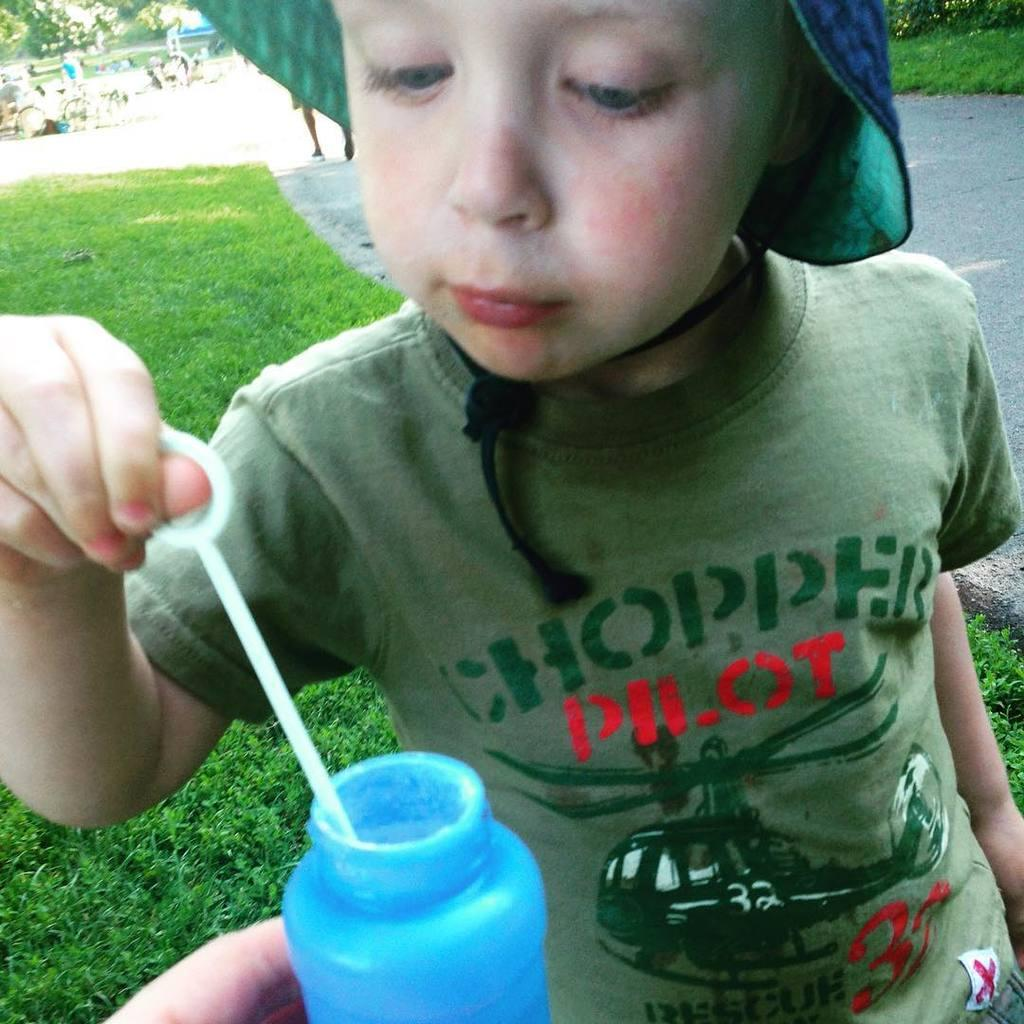What is the main subject of the image? The main subject of the image is a child. What is the child doing in the image? The child is holding an object in his hand. What rule is the child following in the image? There is no specific rule mentioned or depicted in the image. What type of pot is the child holding in the image? There is no pot present in the image; the child is holding an object, but it is not specified as a pot. 